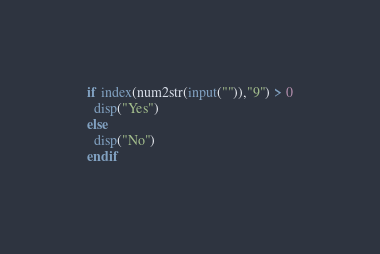Convert code to text. <code><loc_0><loc_0><loc_500><loc_500><_Octave_>if index(num2str(input("")),"9") > 0
  disp("Yes")
else
  disp("No")
endif</code> 